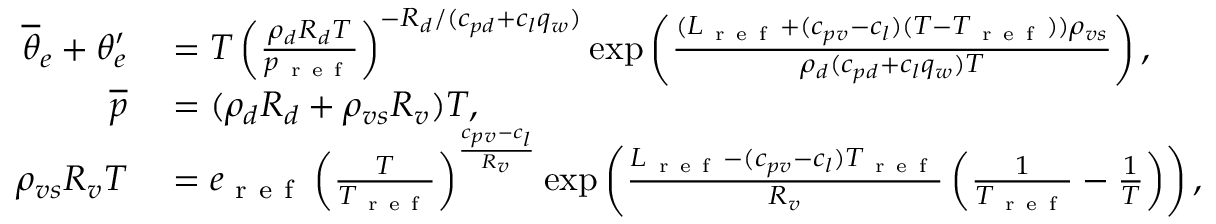Convert formula to latex. <formula><loc_0><loc_0><loc_500><loc_500>\begin{array} { r l } { \overline { \theta } _ { e } + \theta _ { e } ^ { \prime } } & = T \left ( \frac { \rho _ { d } R _ { d } T } { p _ { r e f } } \right ) ^ { - R _ { d } / ( c _ { p d } + c _ { l } q _ { w } ) } \exp \left ( \frac { ( L _ { r e f } + ( c _ { p v } - c _ { l } ) ( T - T _ { r e f } ) ) \rho _ { v s } } { \rho _ { d } ( c _ { p d } + c _ { l } q _ { w } ) T } \right ) , } \\ { \overline { p } } & = ( \rho _ { d } R _ { d } + \rho _ { v s } R _ { v } ) T , } \\ { \rho _ { v s } R _ { v } T } & = e _ { r e f } \left ( \frac { T } { T _ { r e f } } \right ) ^ { \frac { c _ { p v } - c _ { l } } { R _ { v } } } \exp \left ( \frac { L _ { r e f } - ( c _ { p v } - c _ { l } ) T _ { r e f } } { R _ { v } } \left ( \frac { 1 } { T _ { r e f } } - \frac { 1 } { T } \right ) \right ) , } \end{array}</formula> 